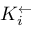<formula> <loc_0><loc_0><loc_500><loc_500>K _ { i } ^ { \leftarrow }</formula> 